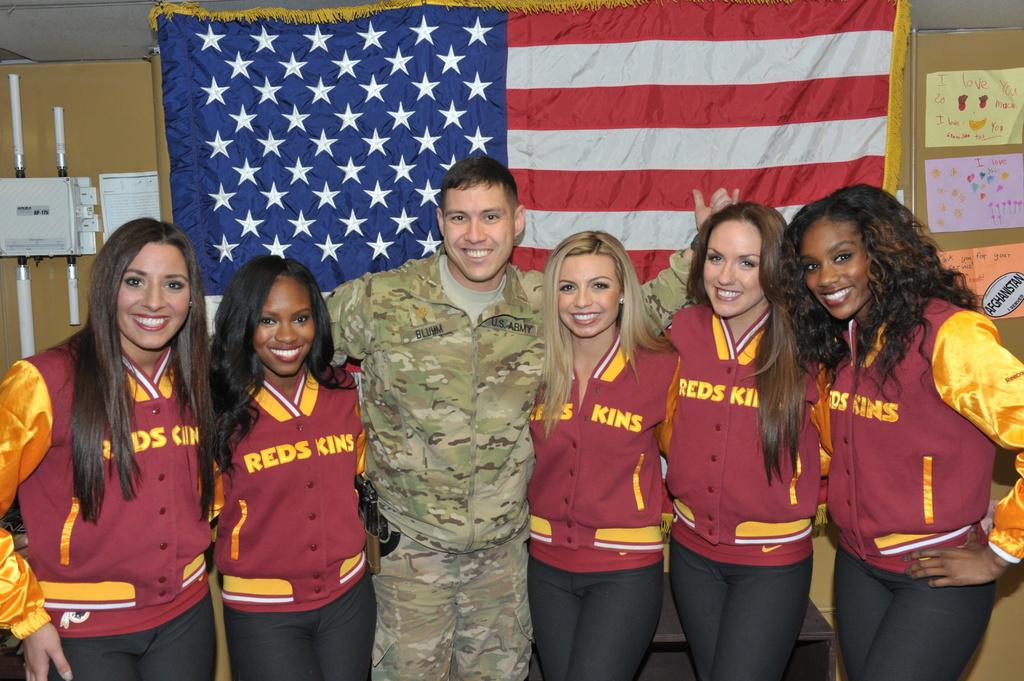<image>
Give a short and clear explanation of the subsequent image. A U.S. Army solder is standing between cheerleaders wearing Redskins jackets. 